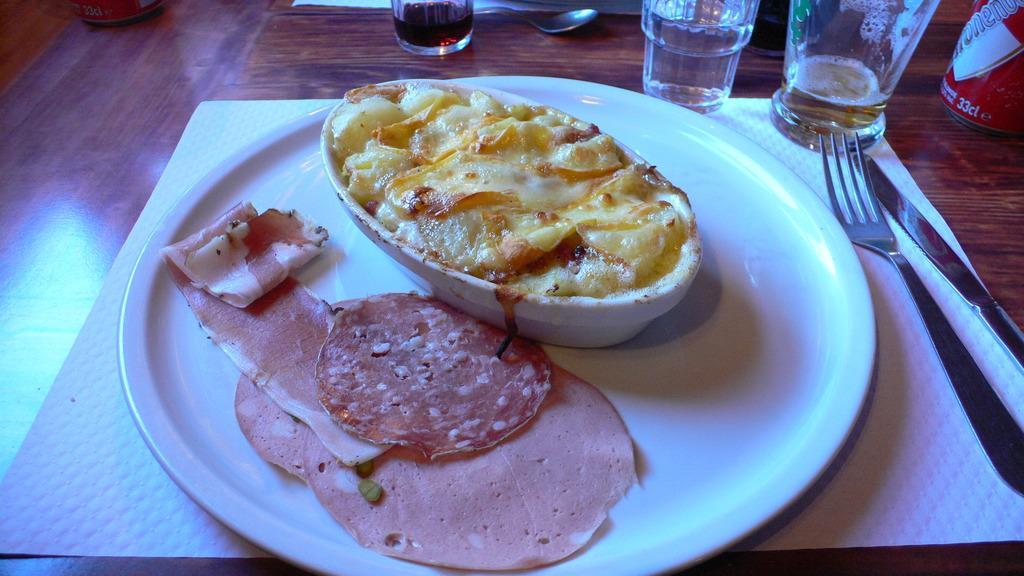Describe this image in one or two sentences. In this image there are food items on the plate and in bowl , tins, glasses, spoon, knife, fork , papers on the table. 